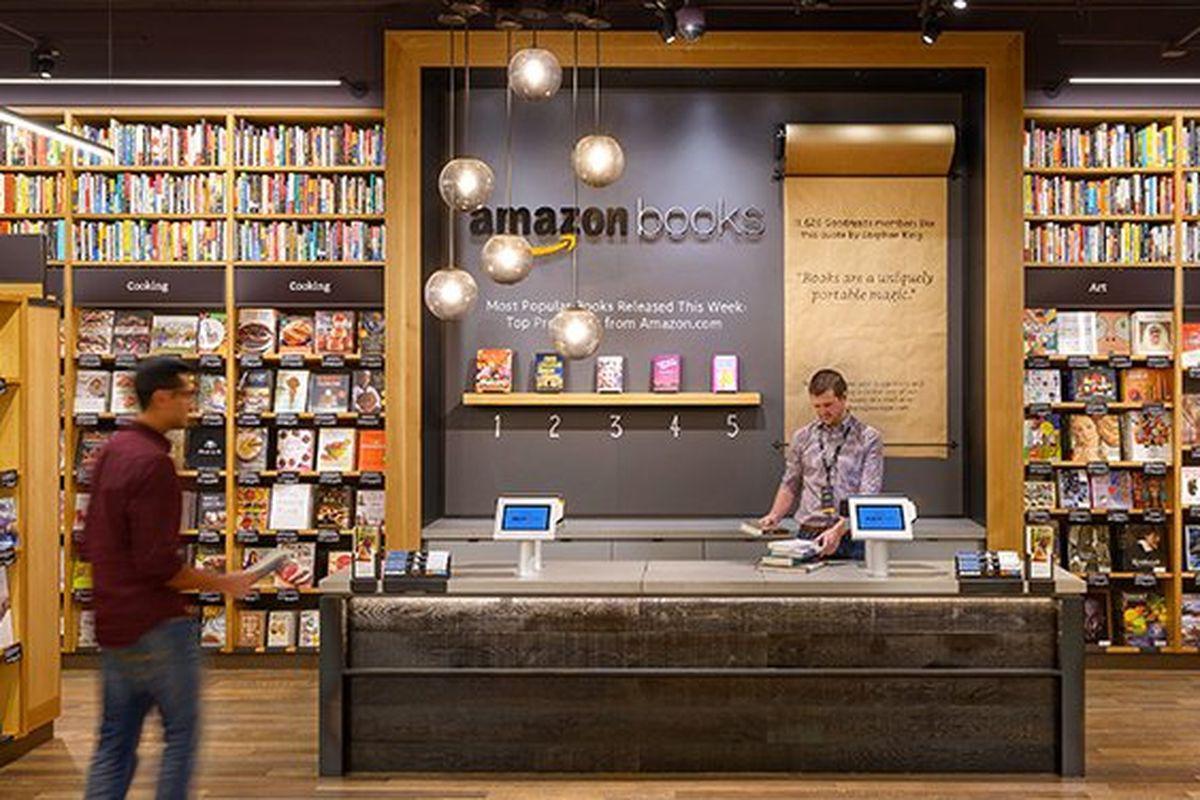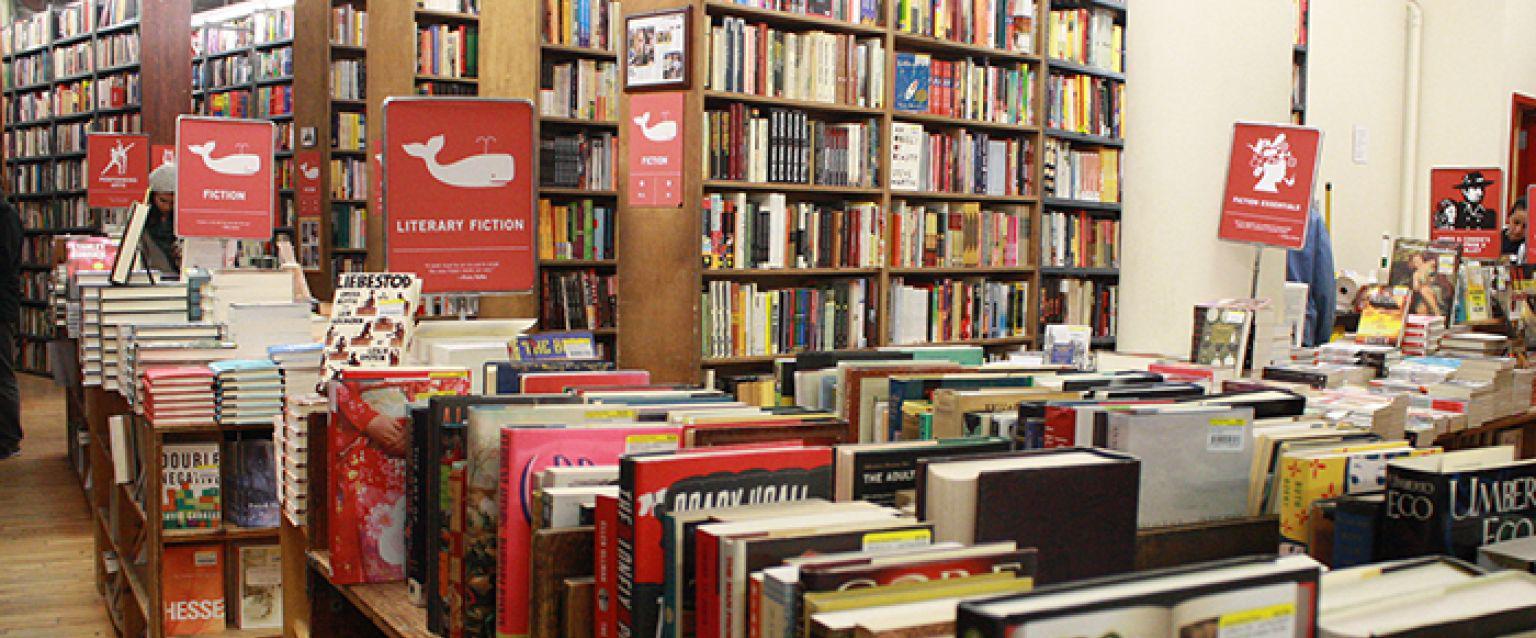The first image is the image on the left, the second image is the image on the right. Analyze the images presented: Is the assertion "One of the images shows humans inside the shop." valid? Answer yes or no. Yes. The first image is the image on the left, the second image is the image on the right. Assess this claim about the two images: "Red rectangular signs with white lettering are displayed above ground-level in one scene.". Correct or not? Answer yes or no. Yes. 